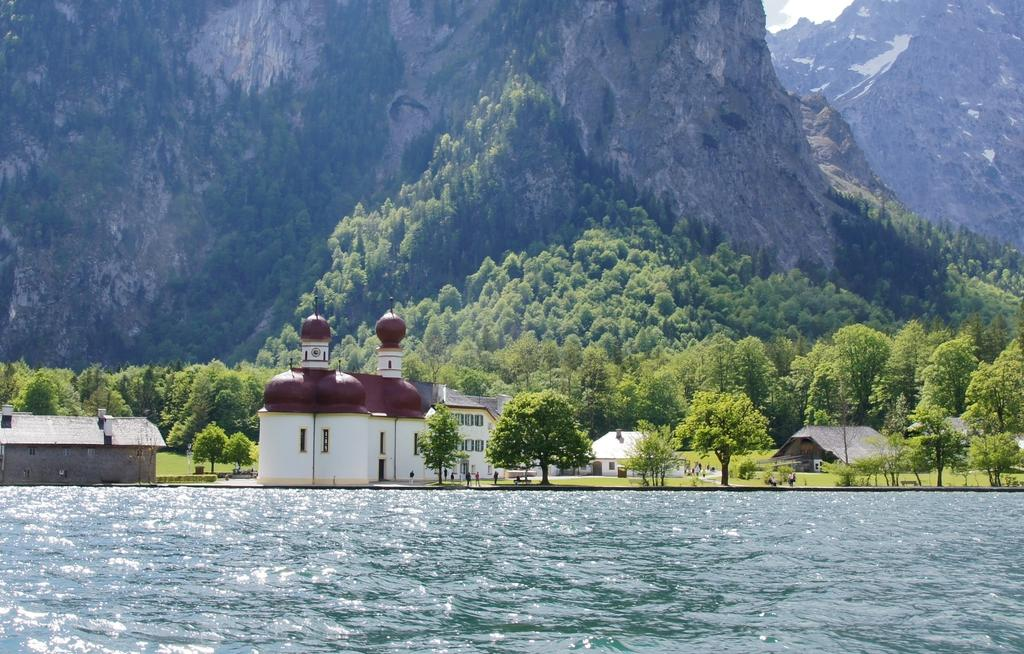What types of structures are present in the image? There are buildings and houses in the image. What natural elements can be seen in the image? There are trees and hills visible in the image. What is the water feature in the image? There is water visible in the image. What type of bulb is being used to cause destruction in the image? There is no bulb or destruction present in the image. Can you describe the pain experienced by the trees in the image? There is no pain experienced by the trees in the image; they are simply visible in the image. 